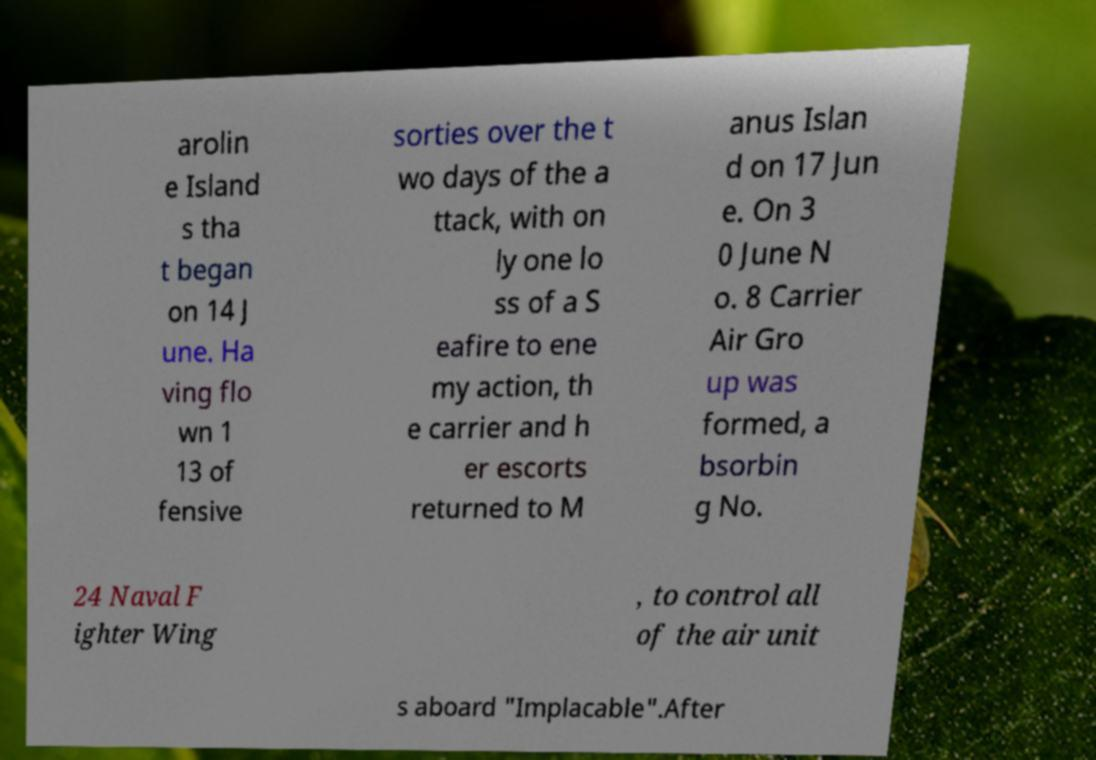Please identify and transcribe the text found in this image. arolin e Island s tha t began on 14 J une. Ha ving flo wn 1 13 of fensive sorties over the t wo days of the a ttack, with on ly one lo ss of a S eafire to ene my action, th e carrier and h er escorts returned to M anus Islan d on 17 Jun e. On 3 0 June N o. 8 Carrier Air Gro up was formed, a bsorbin g No. 24 Naval F ighter Wing , to control all of the air unit s aboard "Implacable".After 